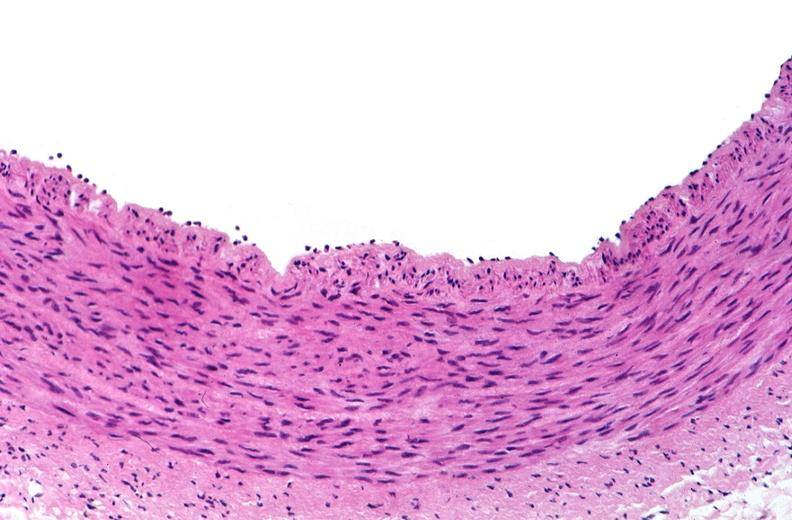does peritoneal fluid show acute inflammation, rolling leukocytes polymorphonuclear neutrophils?
Answer the question using a single word or phrase. No 